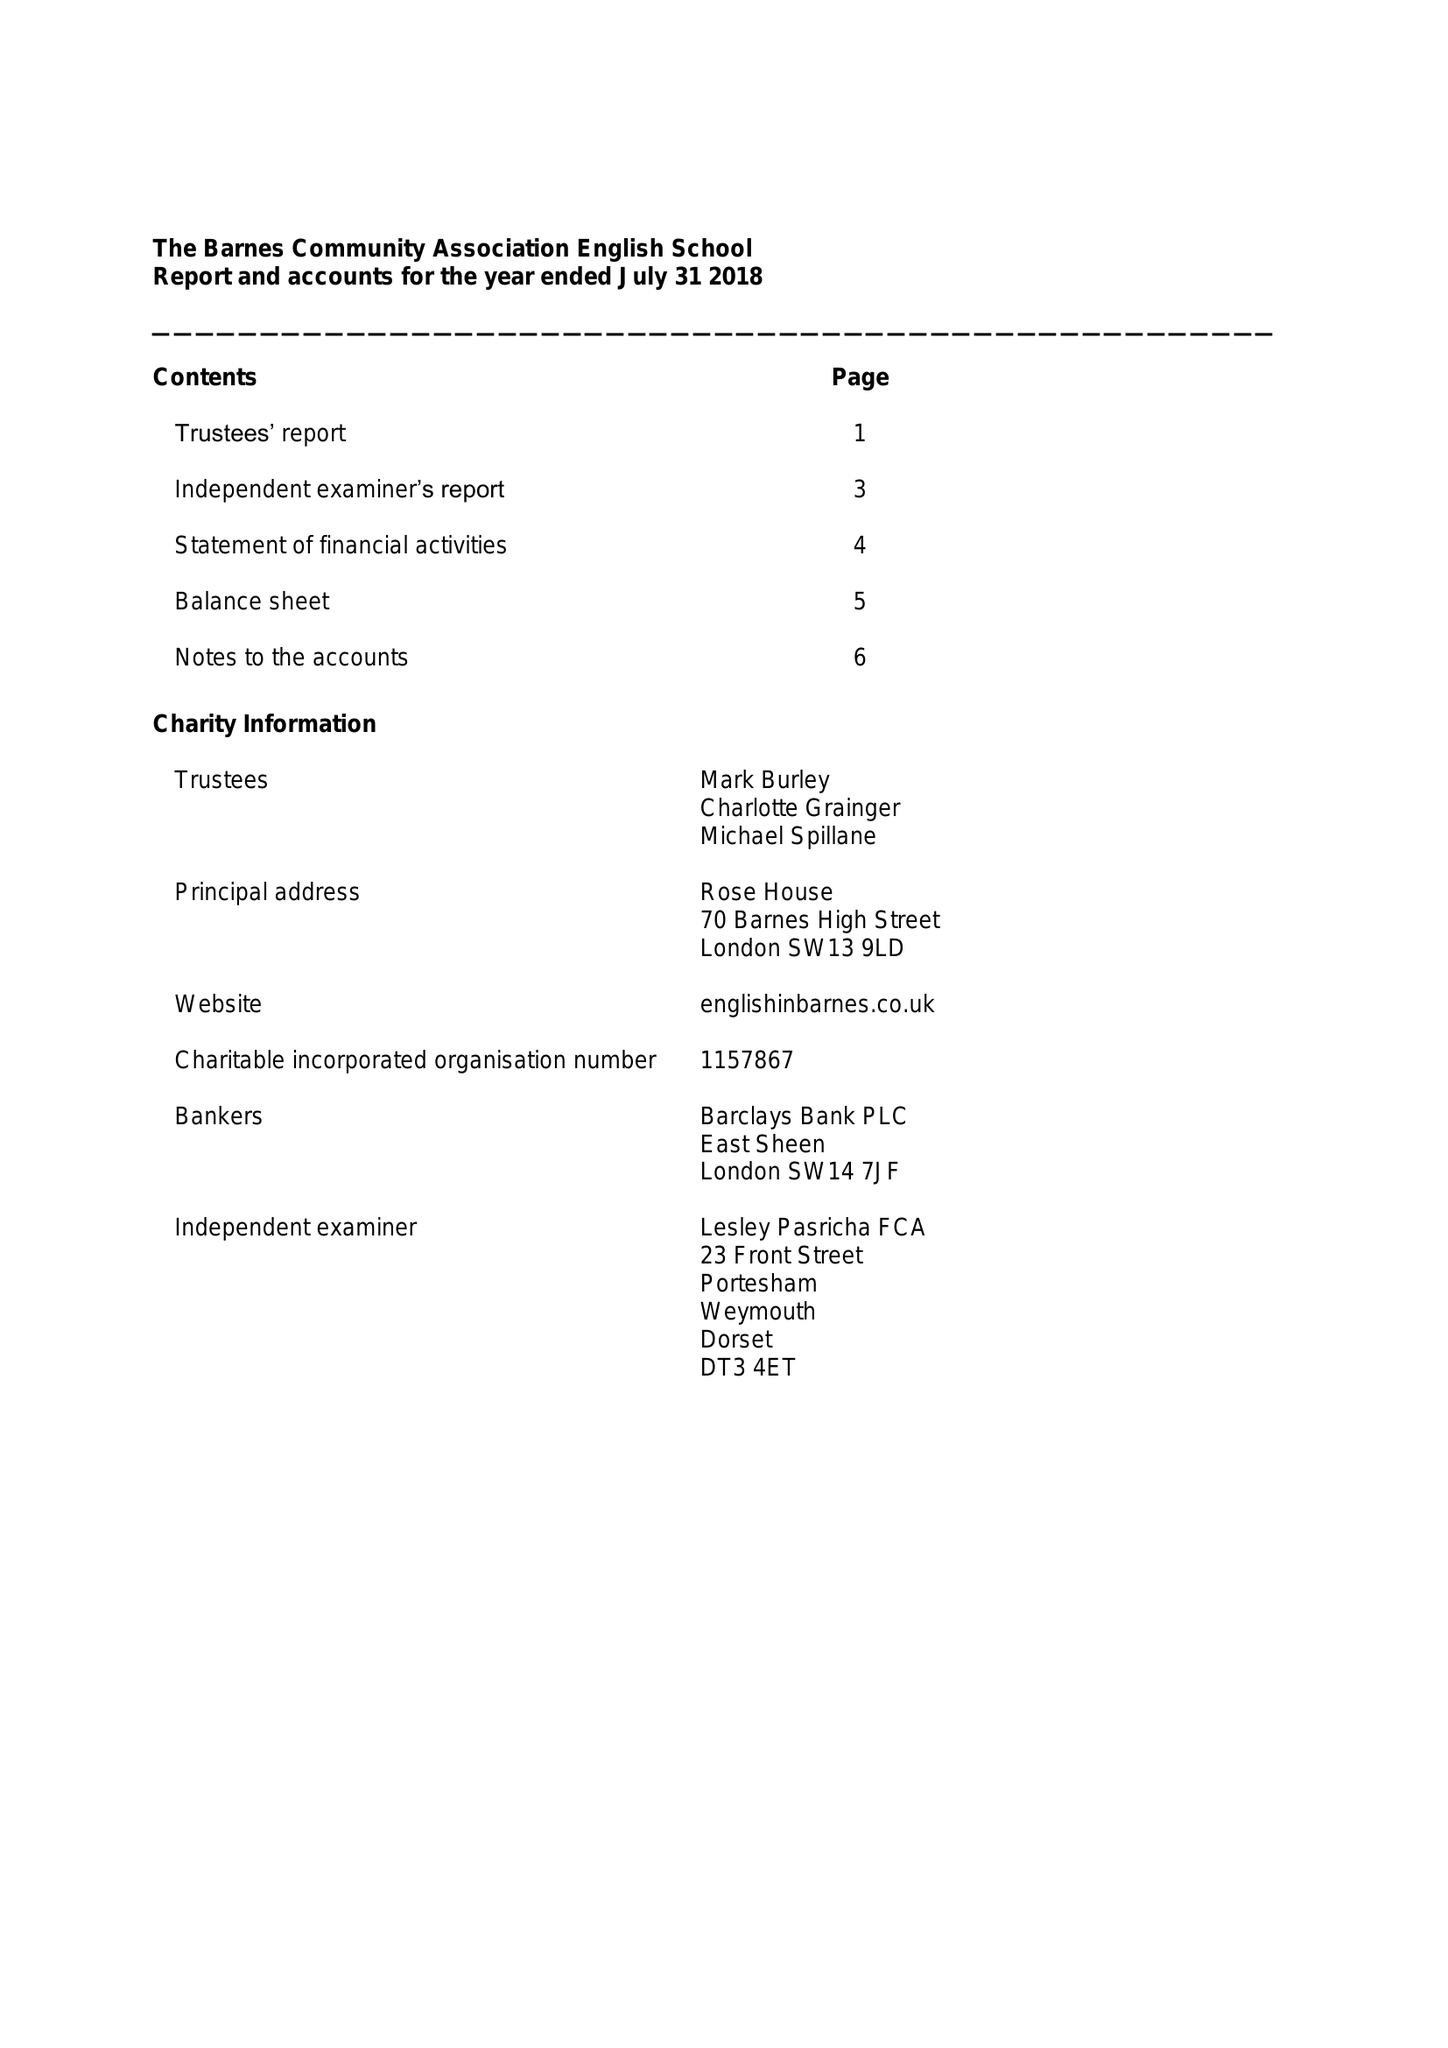What is the value for the income_annually_in_british_pounds?
Answer the question using a single word or phrase. 145738.00 